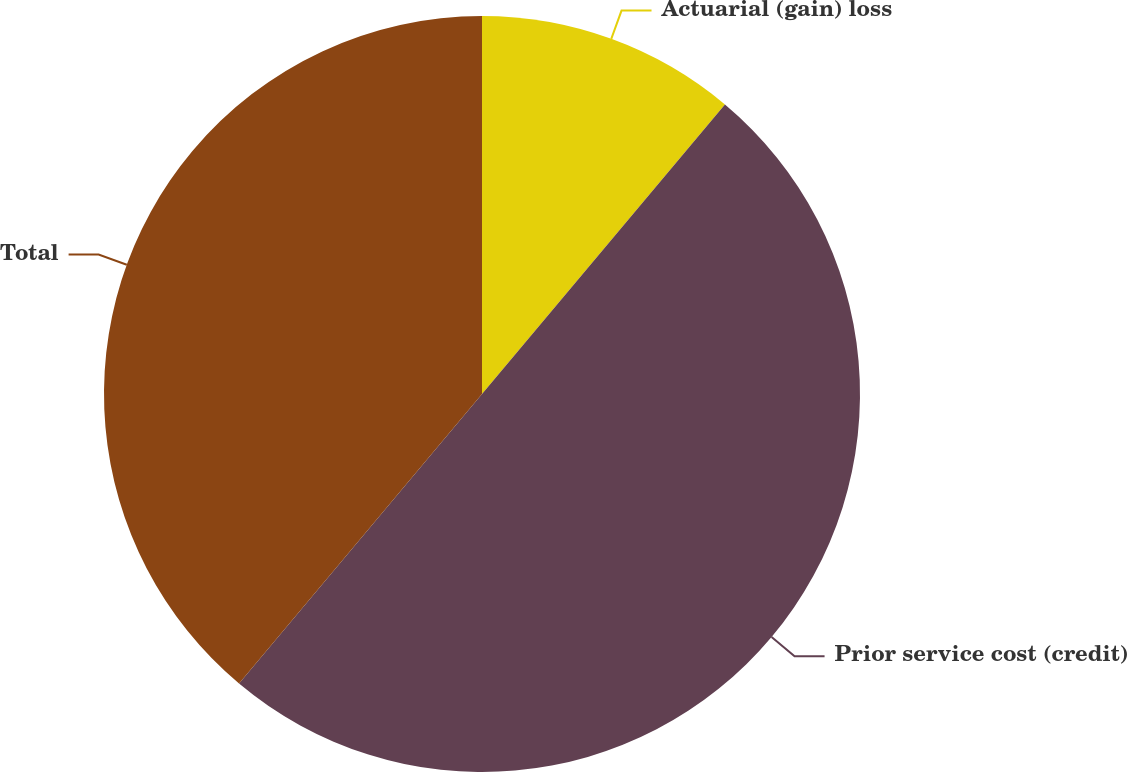Convert chart. <chart><loc_0><loc_0><loc_500><loc_500><pie_chart><fcel>Actuarial (gain) loss<fcel>Prior service cost (credit)<fcel>Total<nl><fcel>11.11%<fcel>50.0%<fcel>38.89%<nl></chart> 